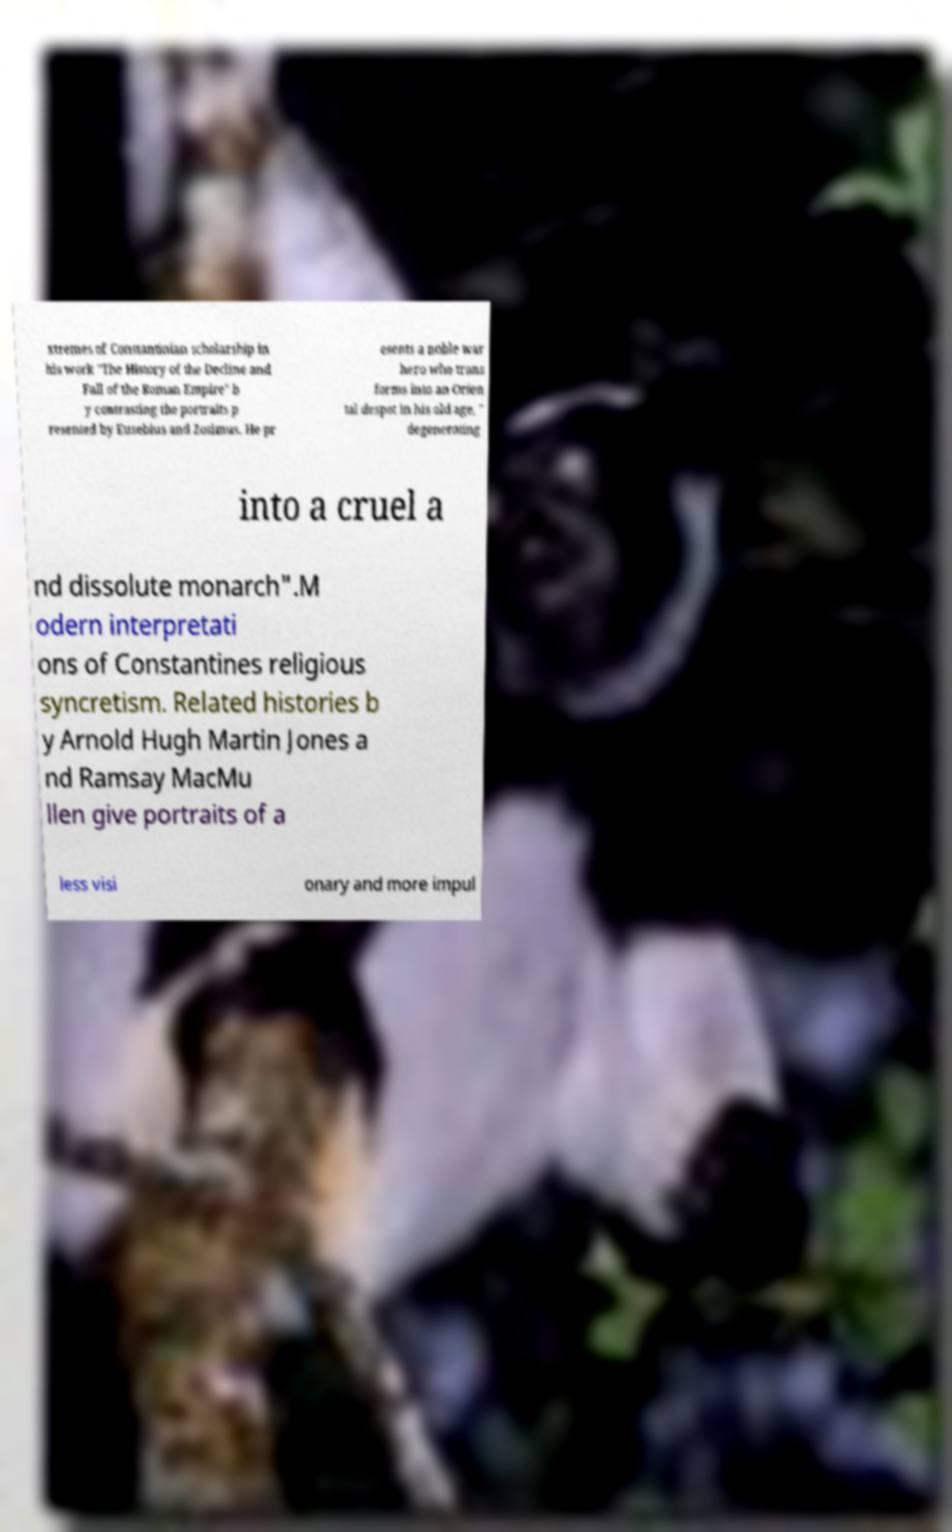Could you extract and type out the text from this image? xtremes of Constantinian scholarship in his work "The History of the Decline and Fall of the Roman Empire" b y contrasting the portraits p resented by Eusebius and Zosimus. He pr esents a noble war hero who trans forms into an Orien tal despot in his old age, " degenerating into a cruel a nd dissolute monarch".M odern interpretati ons of Constantines religious syncretism. Related histories b y Arnold Hugh Martin Jones a nd Ramsay MacMu llen give portraits of a less visi onary and more impul 